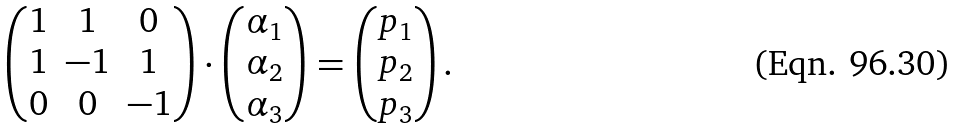Convert formula to latex. <formula><loc_0><loc_0><loc_500><loc_500>\begin{pmatrix} 1 & 1 & 0 \\ 1 & - 1 & 1 \\ 0 & 0 & - 1 \\ \end{pmatrix} \cdot \begin{pmatrix} \alpha _ { 1 } \\ \alpha _ { 2 } \\ \alpha _ { 3 } \\ \end{pmatrix} = \begin{pmatrix} p _ { 1 } \\ p _ { 2 } \\ p _ { 3 } \\ \end{pmatrix} .</formula> 